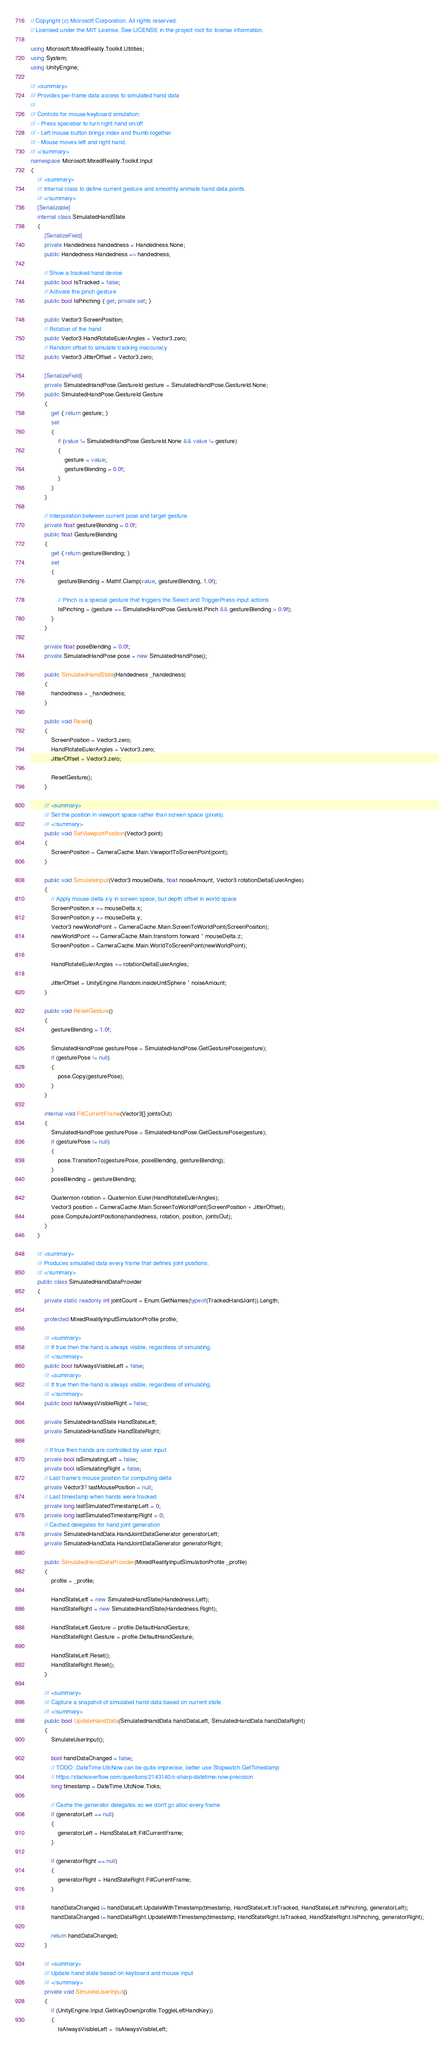Convert code to text. <code><loc_0><loc_0><loc_500><loc_500><_C#_>// Copyright (c) Microsoft Corporation. All rights reserved.
// Licensed under the MIT License. See LICENSE in the project root for license information.

using Microsoft.MixedReality.Toolkit.Utilities;
using System;
using UnityEngine;

/// <summary>
/// Provides per-frame data access to simulated hand data
/// 
/// Controls for mouse/keyboard simulation:
/// - Press spacebar to turn right hand on/off
/// - Left mouse button brings index and thumb together
/// - Mouse moves left and right hand.
/// </summary>
namespace Microsoft.MixedReality.Toolkit.Input
{
    /// <summary>
    /// Internal class to define current gesture and smoothly animate hand data points.
    /// </summary>
    [Serializable]
    internal class SimulatedHandState
    {
        [SerializeField]
        private Handedness handedness = Handedness.None;
        public Handedness Handedness => handedness;

        // Show a tracked hand device
        public bool IsTracked = false;
        // Activate the pinch gesture
        public bool IsPinching { get; private set; }

        public Vector3 ScreenPosition;
        // Rotation of the hand
        public Vector3 HandRotateEulerAngles = Vector3.zero;
        // Random offset to simulate tracking inaccuracy
        public Vector3 JitterOffset = Vector3.zero;

        [SerializeField]
        private SimulatedHandPose.GestureId gesture = SimulatedHandPose.GestureId.None;
        public SimulatedHandPose.GestureId Gesture
        {
            get { return gesture; }
            set
            {
                if (value != SimulatedHandPose.GestureId.None && value != gesture)
                {
                    gesture = value;
                    gestureBlending = 0.0f;
                }
            }
        }

        // Interpolation between current pose and target gesture
        private float gestureBlending = 0.0f;
        public float GestureBlending
        {
            get { return gestureBlending; }
            set
            {
                gestureBlending = Mathf.Clamp(value, gestureBlending, 1.0f);

                // Pinch is a special gesture that triggers the Select and TriggerPress input actions
                IsPinching = (gesture == SimulatedHandPose.GestureId.Pinch && gestureBlending > 0.9f);
            }
        }

        private float poseBlending = 0.0f;
        private SimulatedHandPose pose = new SimulatedHandPose();

        public SimulatedHandState(Handedness _handedness)
        {
            handedness = _handedness;
        }

        public void Reset()
        {
            ScreenPosition = Vector3.zero;
            HandRotateEulerAngles = Vector3.zero;
            JitterOffset = Vector3.zero;

            ResetGesture();
        }

        /// <summary>
        /// Set the position in viewport space rather than screen space (pixels).
        /// </summary>
        public void SetViewportPosition(Vector3 point)
        {
            ScreenPosition = CameraCache.Main.ViewportToScreenPoint(point);
        }

        public void SimulateInput(Vector3 mouseDelta, float noiseAmount, Vector3 rotationDeltaEulerAngles)
        {
            // Apply mouse delta x/y in screen space, but depth offset in world space
            ScreenPosition.x += mouseDelta.x;
            ScreenPosition.y += mouseDelta.y;
            Vector3 newWorldPoint = CameraCache.Main.ScreenToWorldPoint(ScreenPosition);
            newWorldPoint += CameraCache.Main.transform.forward * mouseDelta.z;
            ScreenPosition = CameraCache.Main.WorldToScreenPoint(newWorldPoint);

            HandRotateEulerAngles += rotationDeltaEulerAngles;

            JitterOffset = UnityEngine.Random.insideUnitSphere * noiseAmount;
        }

        public void ResetGesture()
        {
            gestureBlending = 1.0f;

            SimulatedHandPose gesturePose = SimulatedHandPose.GetGesturePose(gesture);
            if (gesturePose != null)
            {
                pose.Copy(gesturePose);
            }
        }

        internal void FillCurrentFrame(Vector3[] jointsOut)
        {
            SimulatedHandPose gesturePose = SimulatedHandPose.GetGesturePose(gesture);
            if (gesturePose != null)
            {
                pose.TransitionTo(gesturePose, poseBlending, gestureBlending);
            }
            poseBlending = gestureBlending;

            Quaternion rotation = Quaternion.Euler(HandRotateEulerAngles);
            Vector3 position = CameraCache.Main.ScreenToWorldPoint(ScreenPosition + JitterOffset);
            pose.ComputeJointPositions(handedness, rotation, position, jointsOut);
        }
    }

    /// <summary>
    /// Produces simulated data every frame that defines joint positions.
    /// </summary>
    public class SimulatedHandDataProvider
    {
        private static readonly int jointCount = Enum.GetNames(typeof(TrackedHandJoint)).Length;

        protected MixedRealityInputSimulationProfile profile;

        /// <summary>
        /// If true then the hand is always visible, regardless of simulating.
        /// </summary>
        public bool IsAlwaysVisibleLeft = false;
        /// <summary>
        /// If true then the hand is always visible, regardless of simulating.
        /// </summary>
        public bool IsAlwaysVisibleRight = false;

        private SimulatedHandState HandStateLeft;
        private SimulatedHandState HandStateRight;

        // If true then hands are controlled by user input
        private bool isSimulatingLeft = false;
        private bool isSimulatingRight = false;
        // Last frame's mouse position for computing delta
        private Vector3? lastMousePosition = null;
        // Last timestamp when hands were tracked
        private long lastSimulatedTimestampLeft = 0;
        private long lastSimulatedTimestampRight = 0;
        // Cached delegates for hand joint generation
        private SimulatedHandData.HandJointDataGenerator generatorLeft;
        private SimulatedHandData.HandJointDataGenerator generatorRight;

        public SimulatedHandDataProvider(MixedRealityInputSimulationProfile _profile)
        {
            profile = _profile;

            HandStateLeft = new SimulatedHandState(Handedness.Left);
            HandStateRight = new SimulatedHandState(Handedness.Right);

            HandStateLeft.Gesture = profile.DefaultHandGesture;
            HandStateRight.Gesture = profile.DefaultHandGesture;

            HandStateLeft.Reset();
            HandStateRight.Reset();
        }

        /// <summary>
        /// Capture a snapshot of simulated hand data based on current state.
        /// </summary>
        public bool UpdateHandData(SimulatedHandData handDataLeft, SimulatedHandData handDataRight)
        {
            SimulateUserInput();

            bool handDataChanged = false;
            // TODO: DateTime.UtcNow can be quite imprecise, better use Stopwatch.GetTimestamp
            // https://stackoverflow.com/questions/2143140/c-sharp-datetime-now-precision
            long timestamp = DateTime.UtcNow.Ticks;

            // Cache the generator delegates so we don't gc alloc every frame
            if (generatorLeft == null)
            {
                generatorLeft = HandStateLeft.FillCurrentFrame;
            }

            if (generatorRight == null)
            {
                generatorRight = HandStateRight.FillCurrentFrame;
            }

            handDataChanged |= handDataLeft.UpdateWithTimestamp(timestamp, HandStateLeft.IsTracked, HandStateLeft.IsPinching, generatorLeft);
            handDataChanged |= handDataRight.UpdateWithTimestamp(timestamp, HandStateRight.IsTracked, HandStateRight.IsPinching, generatorRight);

            return handDataChanged;
        }

        /// <summary>
        /// Update hand state based on keyboard and mouse input
        /// </summary>
        private void SimulateUserInput()
        {
            if (UnityEngine.Input.GetKeyDown(profile.ToggleLeftHandKey))
            {
                IsAlwaysVisibleLeft = !IsAlwaysVisibleLeft;</code> 